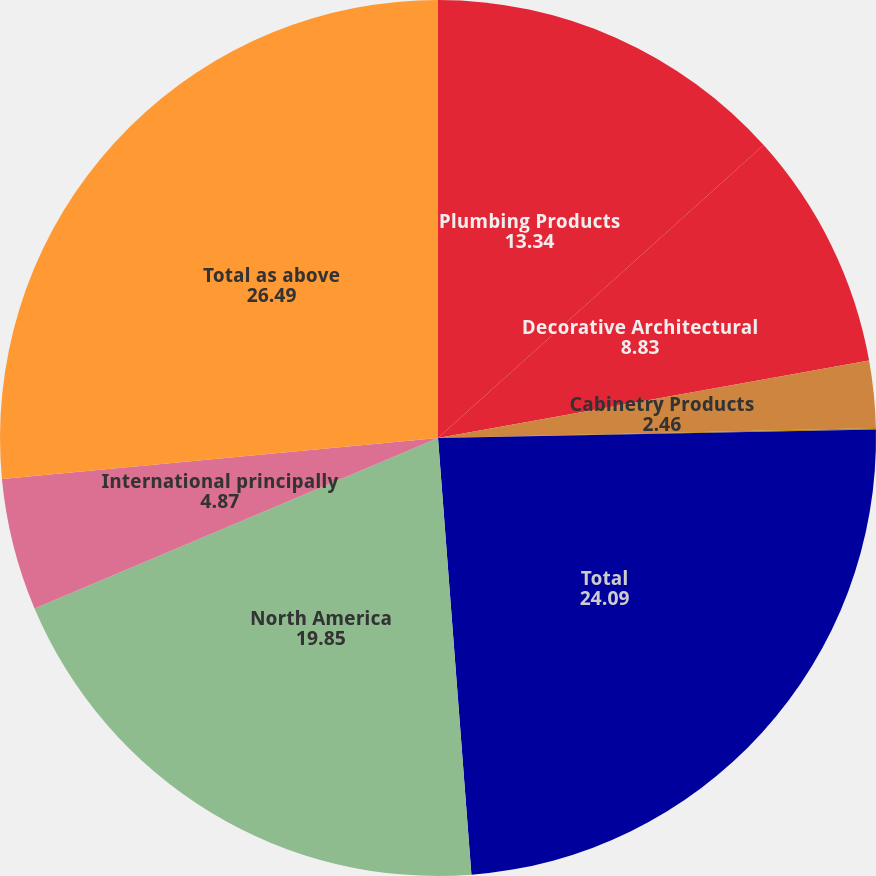<chart> <loc_0><loc_0><loc_500><loc_500><pie_chart><fcel>Plumbing Products<fcel>Decorative Architectural<fcel>Cabinetry Products<fcel>Windows and Other Specialty<fcel>Total<fcel>North America<fcel>International principally<fcel>Total as above<nl><fcel>13.34%<fcel>8.83%<fcel>2.46%<fcel>0.06%<fcel>24.09%<fcel>19.85%<fcel>4.87%<fcel>26.49%<nl></chart> 